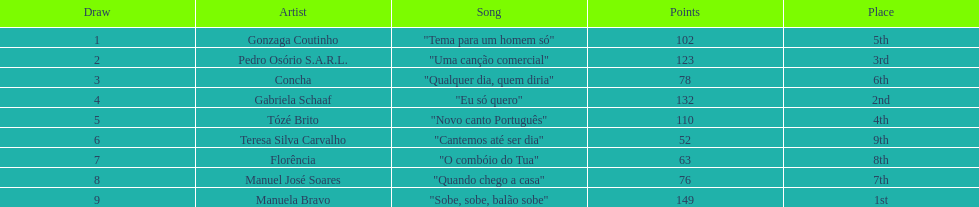Which artist finished at the bottom? Teresa Silva Carvalho. Could you help me parse every detail presented in this table? {'header': ['Draw', 'Artist', 'Song', 'Points', 'Place'], 'rows': [['1', 'Gonzaga Coutinho', '"Tema para um homem só"', '102', '5th'], ['2', 'Pedro Osório S.A.R.L.', '"Uma canção comercial"', '123', '3rd'], ['3', 'Concha', '"Qualquer dia, quem diria"', '78', '6th'], ['4', 'Gabriela Schaaf', '"Eu só quero"', '132', '2nd'], ['5', 'Tózé Brito', '"Novo canto Português"', '110', '4th'], ['6', 'Teresa Silva Carvalho', '"Cantemos até ser dia"', '52', '9th'], ['7', 'Florência', '"O combóio do Tua"', '63', '8th'], ['8', 'Manuel José Soares', '"Quando chego a casa"', '76', '7th'], ['9', 'Manuela Bravo', '"Sobe, sobe, balão sobe"', '149', '1st']]} 